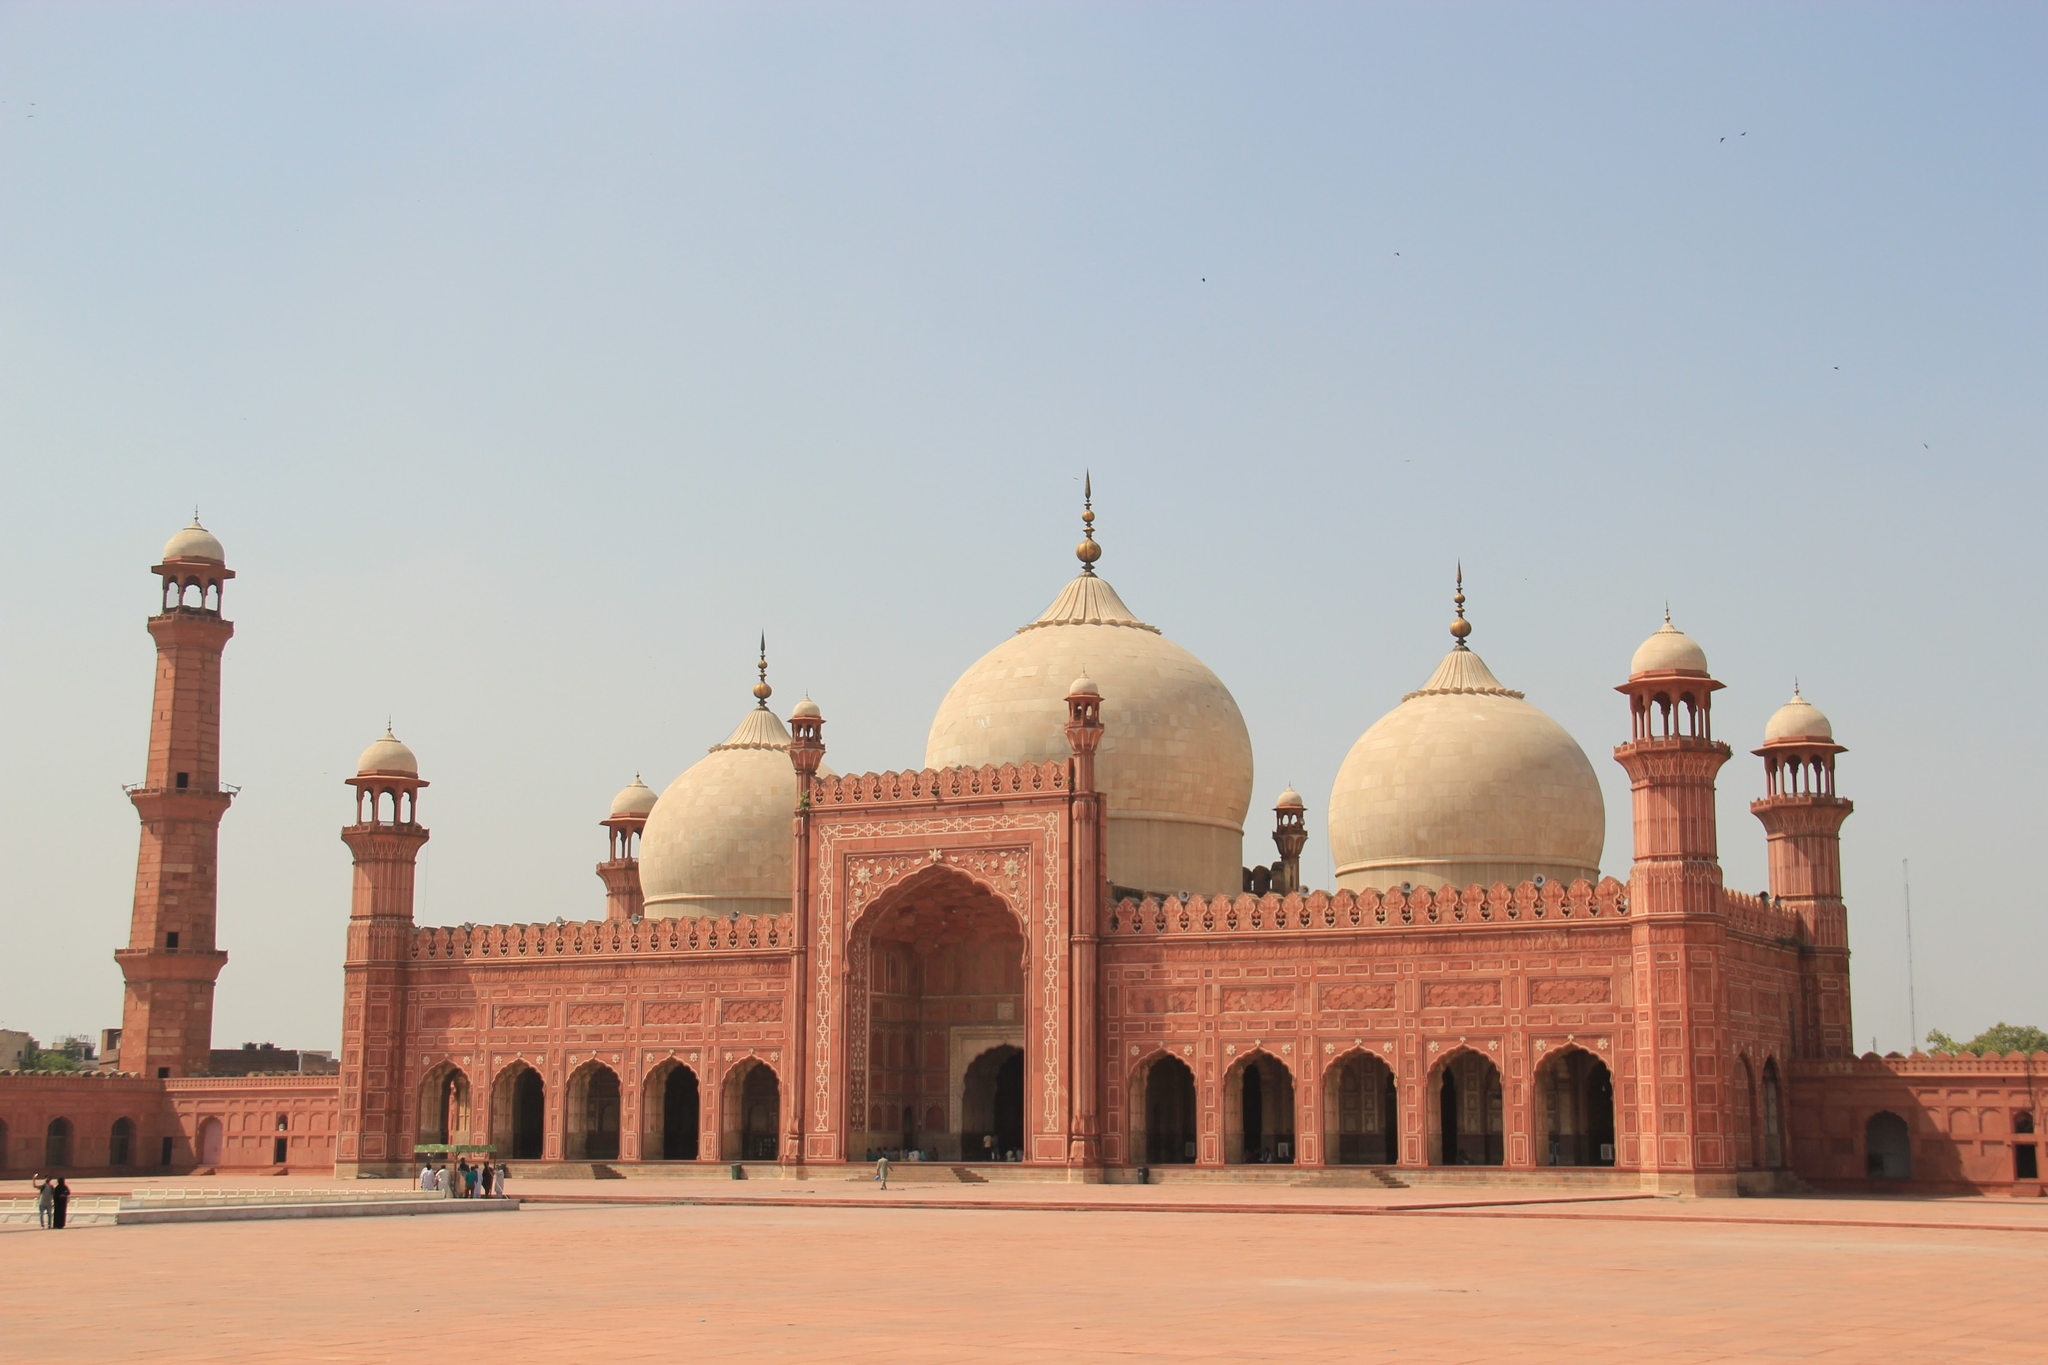What are the key elements in this picture? The image showcases the majestic Badshahi Mosque, a pinnacle of Mughal architecture located in Lahore, Pakistan. Notable for its grand size and intricate artistry, the mosque is constructed from red sandstone with white marble domes that shine brilliantly under the sun. The mosque's design includes detailed Islamic calligraphy and geometric patterns that adorn its exterior and entrance gate. This historic edifice is flanked by towering minarets, characteristic of Mughal architecture, which serve both as architectural feats and spiritual symbols. In the foreground, the blurry presence of people adds a dynamic human element, illustrating the mosque's ongoing role as a place of worship and cultural convergence. 